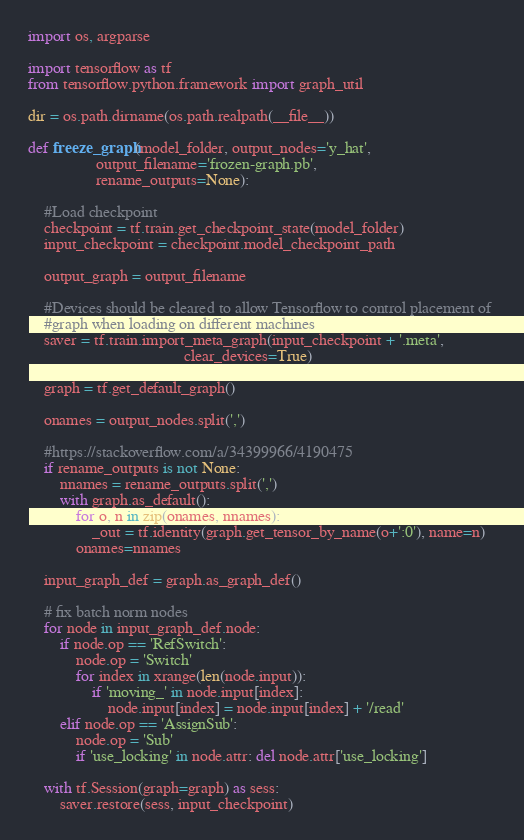<code> <loc_0><loc_0><loc_500><loc_500><_Python_>import os, argparse

import tensorflow as tf
from tensorflow.python.framework import graph_util

dir = os.path.dirname(os.path.realpath(__file__))

def freeze_graph(model_folder, output_nodes='y_hat', 
                 output_filename='frozen-graph.pb', 
                 rename_outputs=None):

    #Load checkpoint 
    checkpoint = tf.train.get_checkpoint_state(model_folder)
    input_checkpoint = checkpoint.model_checkpoint_path
    
    output_graph = output_filename

    #Devices should be cleared to allow Tensorflow to control placement of 
    #graph when loading on different machines
    saver = tf.train.import_meta_graph(input_checkpoint + '.meta', 
                                       clear_devices=True)

    graph = tf.get_default_graph()

    onames = output_nodes.split(',')

    #https://stackoverflow.com/a/34399966/4190475
    if rename_outputs is not None:
        nnames = rename_outputs.split(',')
        with graph.as_default():
            for o, n in zip(onames, nnames):
                _out = tf.identity(graph.get_tensor_by_name(o+':0'), name=n)
            onames=nnames

    input_graph_def = graph.as_graph_def()

    # fix batch norm nodes
    for node in input_graph_def.node:
        if node.op == 'RefSwitch':
            node.op = 'Switch'
            for index in xrange(len(node.input)):
                if 'moving_' in node.input[index]:
                    node.input[index] = node.input[index] + '/read'
        elif node.op == 'AssignSub':
            node.op = 'Sub'
            if 'use_locking' in node.attr: del node.attr['use_locking']

    with tf.Session(graph=graph) as sess:
        saver.restore(sess, input_checkpoint)
</code> 